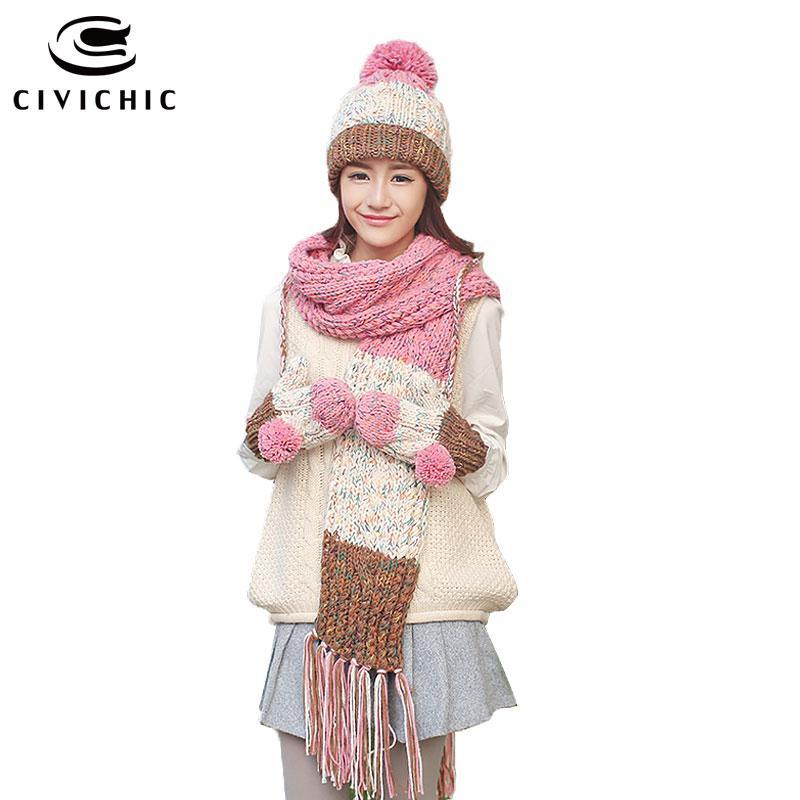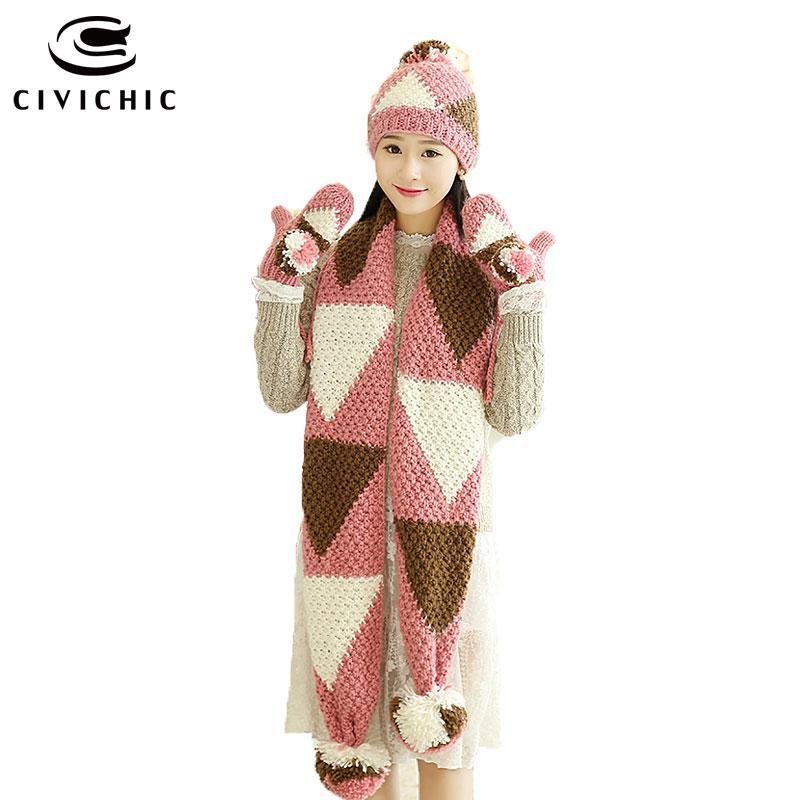The first image is the image on the left, the second image is the image on the right. Evaluate the accuracy of this statement regarding the images: "There is a girl with her mouth covered.". Is it true? Answer yes or no. No. 